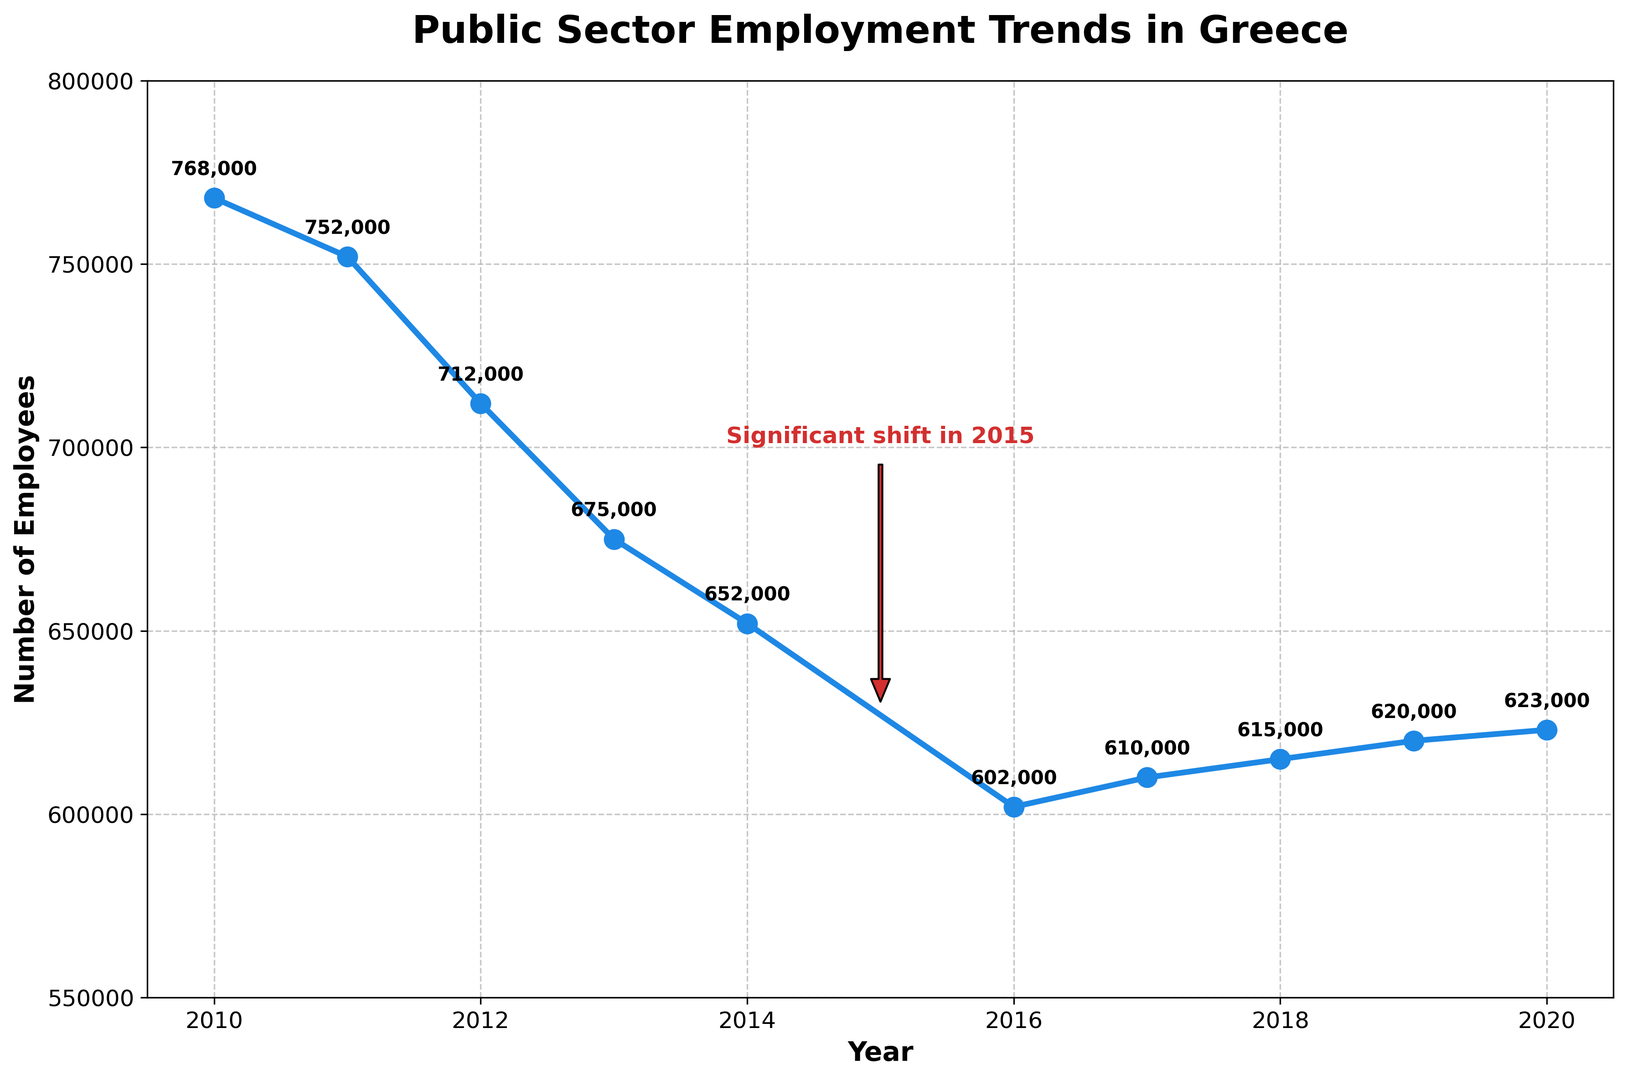What trend do you observe in public sector employment in Greece from 2010 to 2015? From 2010 to 2015, there is a noticeable decline in the number of public sector employees year by year. Employment dropped from 768,000 in 2010 to 652,000 in 2014 and remains the same in 2015.
Answer: Decline What is the significant shift annotated in the plot? The plot includes an annotation marking a "Significant shift in 2015". This indicates a notable change or event in 2015 affecting public sector employment trends.
Answer: 2015 How many public sector employees were there in 2020? By looking at the data for the year 2020 on the plot, we can see a label marking the employee count. The number is 623,000.
Answer: 623,000 Compare the number of public sector employees in 2011 and 2014. The number of public sector employees in 2011 was 752,000, while in 2014 it was 652,000. This means there was a decrease of 100,000 employees over these years.
Answer: Decrease by 100,000 Which year experienced the lowest number of public sector employees, and what was the count? The lowest point in the plot occurs in 2016, where the number of public sector employees was 602,000.
Answer: 2016, 602,000 Calculate the average number of public sector employees from 2017 to 2020. The numbers from 2017 to 2020 are 610,000, 615,000, 620,000, and 623,000. Their sum is 2,468,000. Dividing by 4 (the number of years) gives an average of 617,000.
Answer: 617,000 Has the number of public sector employees increased or decreased from 2016 to 2020? Observing the plot from 2016 to 2020, we see an increasing trend. The number rose from 602,000 in 2016 to 623,000 in 2020.
Answer: Increased What is the total decline in public sector employment from 2010 to 2016? The number of employees in 2010 was 768,000, and it declined to 602,000 in 2016. The total decline is 768,000 - 602,000 = 166,000.
Answer: 166,000 Describe the trend in public sector employment from 2017 to 2018. The plot shows a slight increase in the number of employees, from 610,000 in 2017 to 615,000 in 2018.
Answer: Increase 